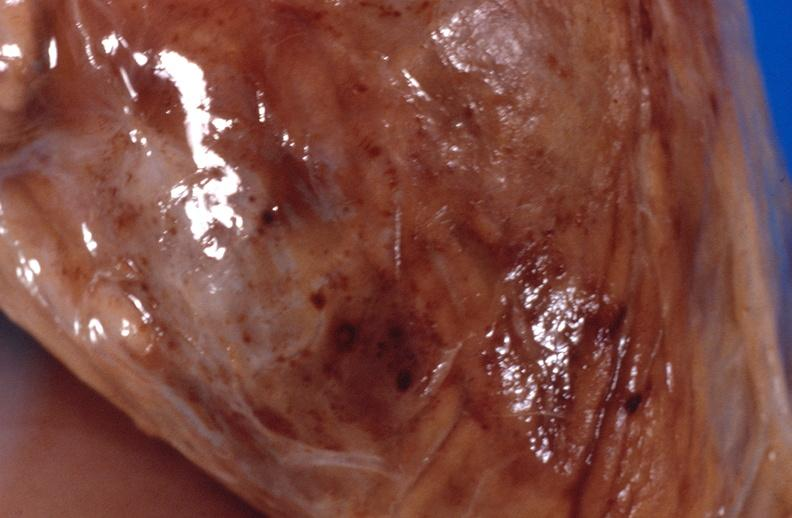s soft tissue present?
Answer the question using a single word or phrase. Yes 